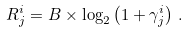<formula> <loc_0><loc_0><loc_500><loc_500>R _ { j } ^ { i } = B \times \log _ { 2 } \left ( { 1 + \gamma ^ { i } _ { j } } \right ) \, .</formula> 